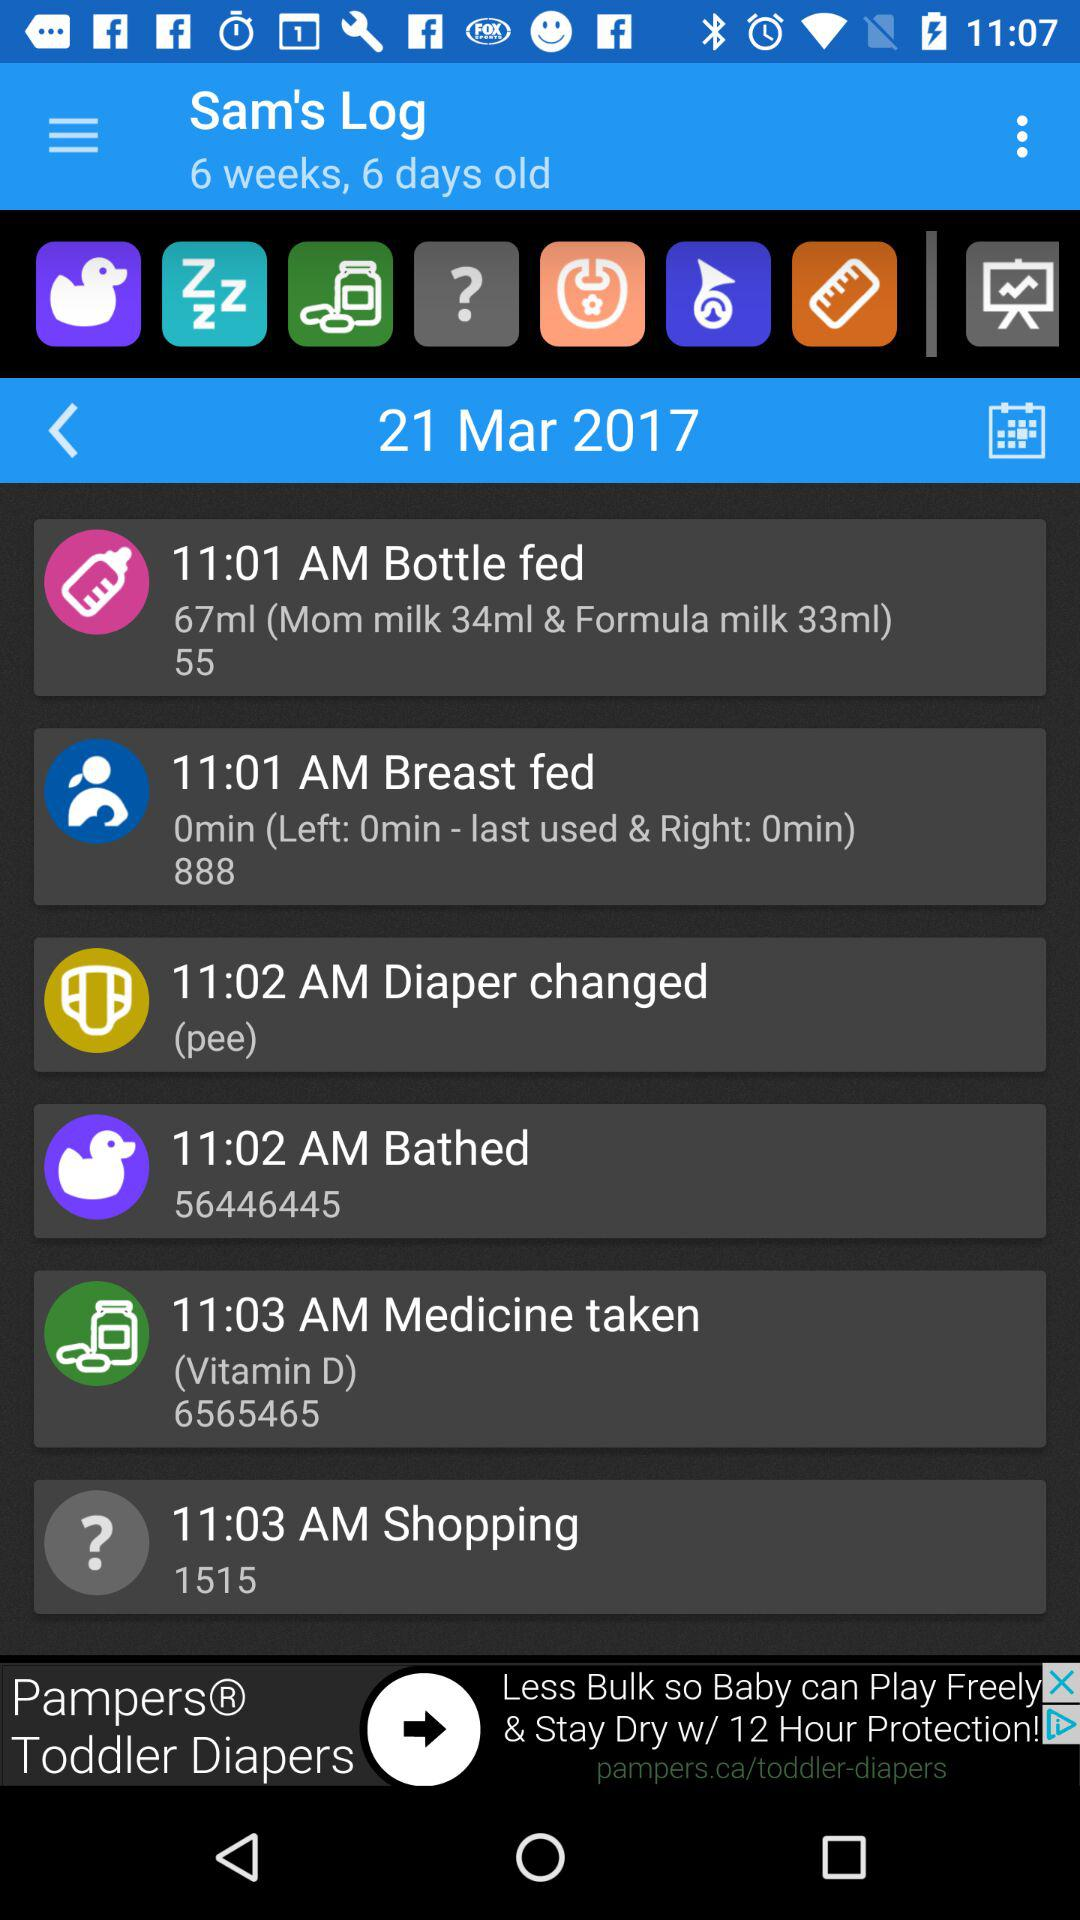Which date is selected from the calendar? The selected date is March 21, 2017. 